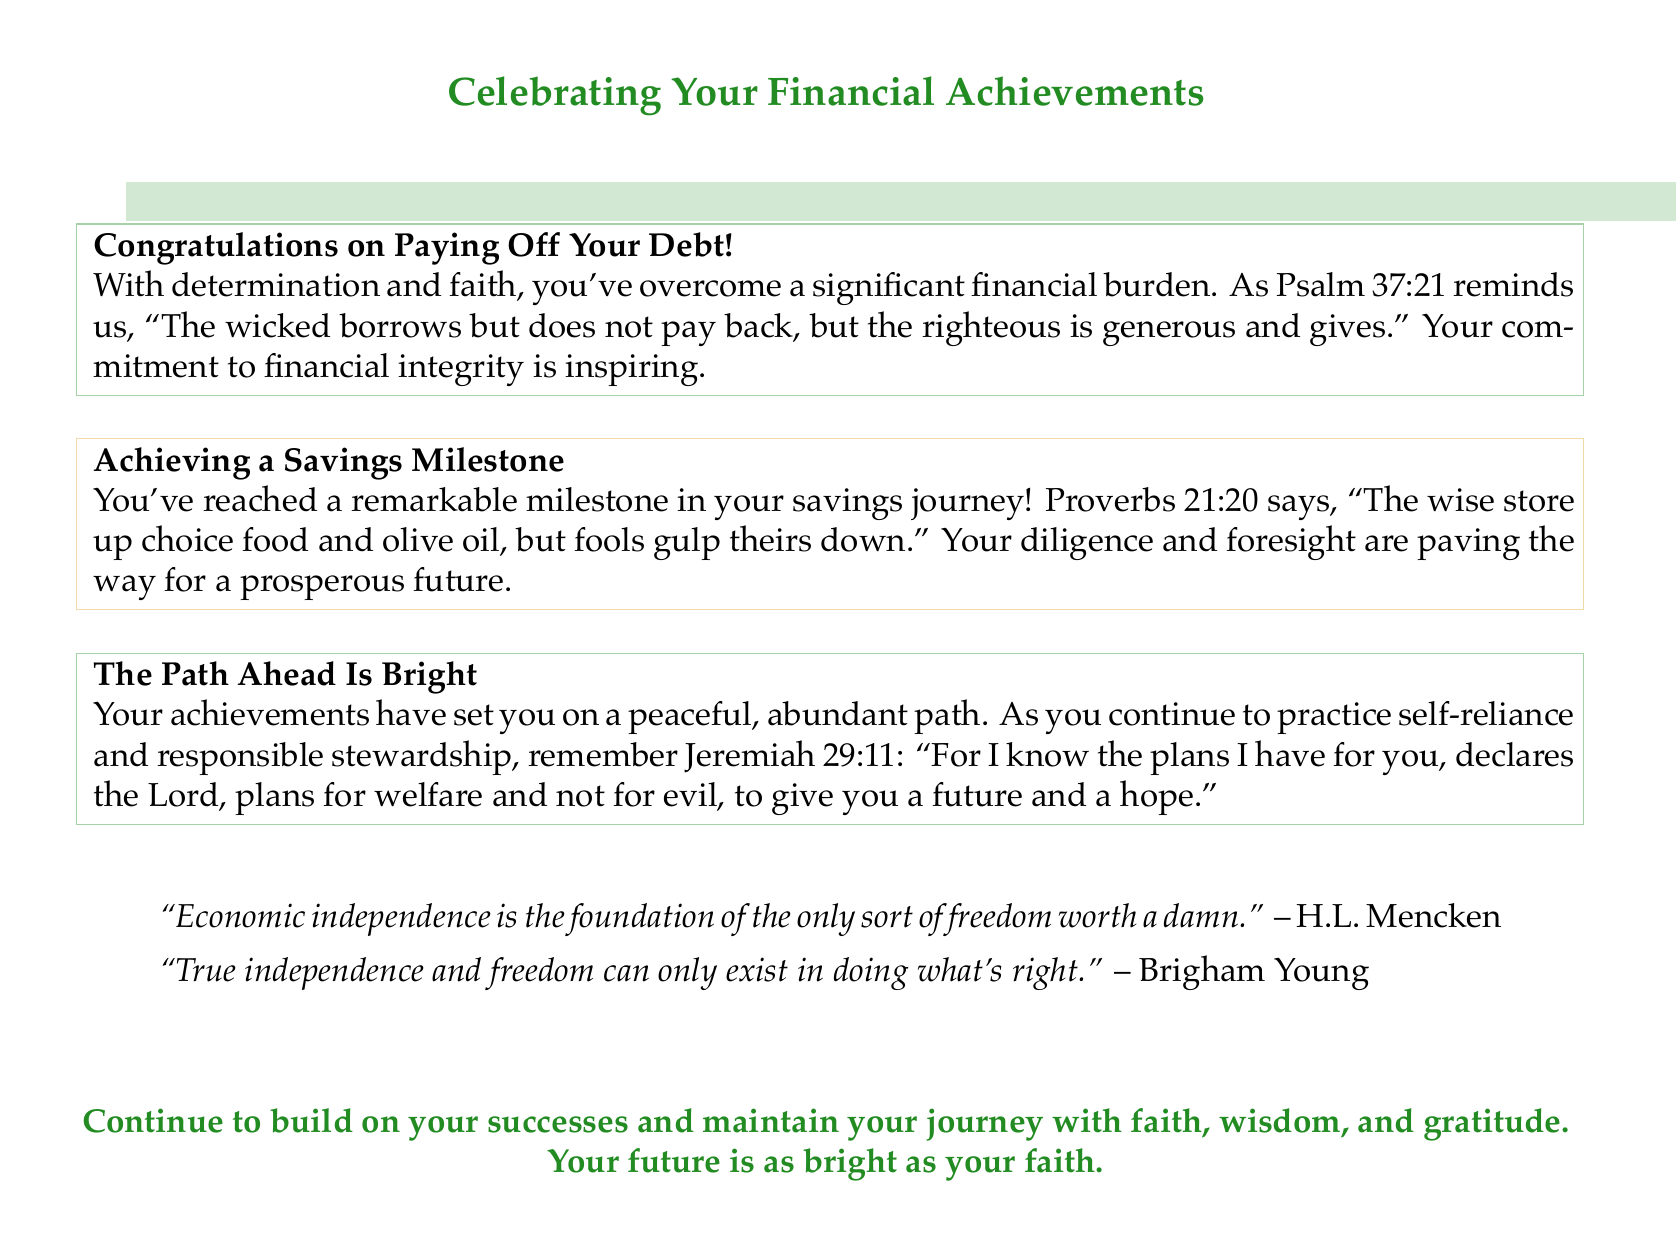What is the main theme of the card? The main theme of the card revolves around celebrating financial achievements.
Answer: Celebrating financial achievements What biblical verse is mentioned regarding debt? The card cites Psalm 37:21 concerning the importance of paying back debt.
Answer: Psalm 37:21 What color is used for the congratulatory box about paying off debt? The box celebrates paying off debt and is shaded in forest green.
Answer: Forest green Which financial milestone is highlighted after paying off debt? The card mentions achieving a savings milestone following the debt payoff.
Answer: Achieving a savings milestone What does Proverbs 21:20 emphasize about savings? The card uses Proverbs 21:20 to highlight the wisdom in storing resources.
Answer: Wisdom in storing resources What inspirational quote is attributed to Brigham Young? The card includes a quote that speaks to true independence and freedom.
Answer: True independence and freedom can only exist in doing what's right How does the card suggest continuing on the path of financial success? The card encourages continuing with faith, wisdom, and gratitude.
Answer: Faith, wisdom, and gratitude What color represents the box for achieving a savings milestone? The box for the savings milestone is represented by the color goldenrod.
Answer: Goldenrod What does the card say about the future? The card indicates that the future is described as bright and abundant.
Answer: Bright and abundant 